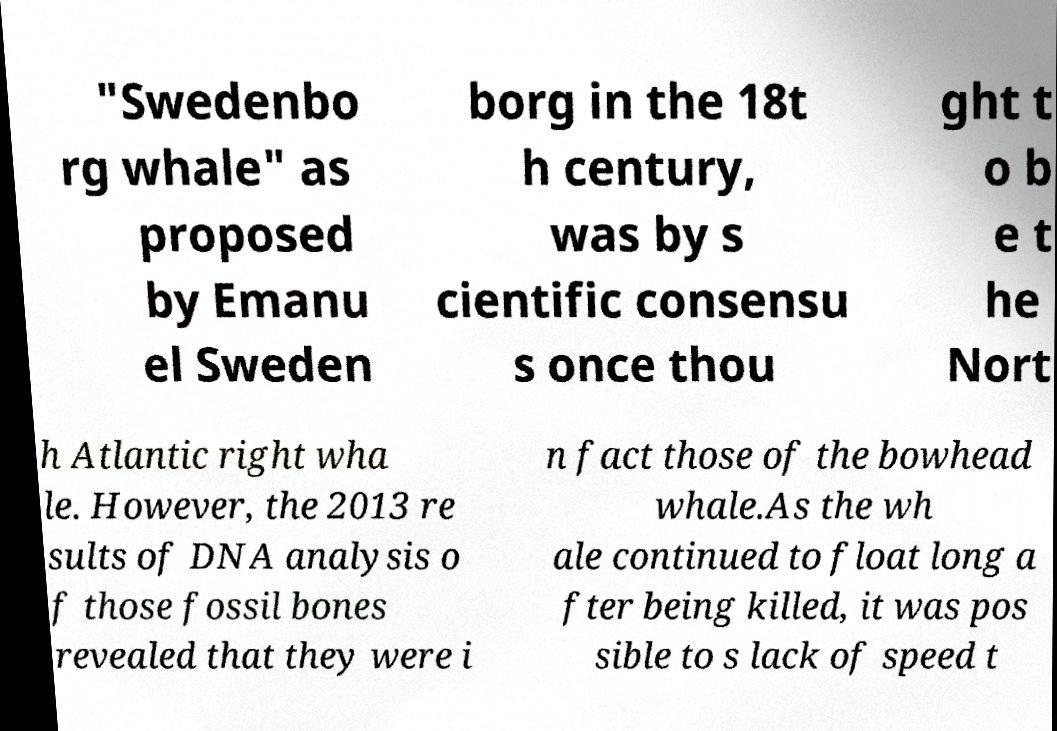Could you assist in decoding the text presented in this image and type it out clearly? "Swedenbo rg whale" as proposed by Emanu el Sweden borg in the 18t h century, was by s cientific consensu s once thou ght t o b e t he Nort h Atlantic right wha le. However, the 2013 re sults of DNA analysis o f those fossil bones revealed that they were i n fact those of the bowhead whale.As the wh ale continued to float long a fter being killed, it was pos sible to s lack of speed t 